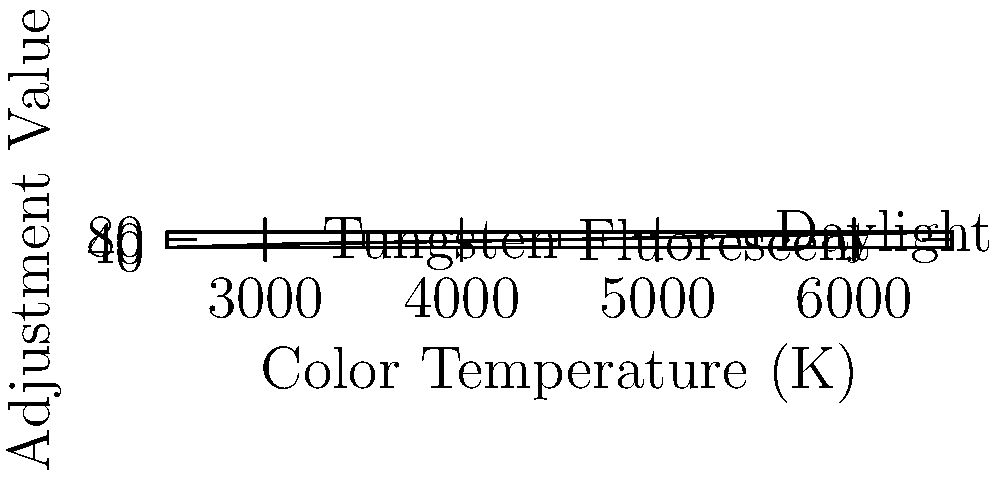In a studio setup, you're working with mixed lighting: a tungsten key light (3200K) and fluorescent fill lights (4500K). The camera is set to daylight white balance (5500K). Using the graph, calculate the total color temperature adjustment needed to balance the scene to the camera's white balance. 1. Identify the adjustment values from the graph:
   - Tungsten (3200K): 20
   - Fluorescent (4500K): 40
   - Daylight (5500K): 60

2. Calculate the difference between the camera's white balance and each light source:
   - Tungsten: 60 - 20 = 40
   - Fluorescent: 60 - 40 = 20

3. As the key light (tungsten) is the primary light source, we'll use its adjustment as the base:
   Tungsten adjustment: 40

4. The fill light (fluorescent) contributes less, so we'll add half of its adjustment:
   Fluorescent contribution: 20 / 2 = 10

5. Sum the adjustments:
   Total adjustment = Tungsten adjustment + Fluorescent contribution
   Total adjustment = 40 + 10 = 50

This means a total adjustment of +50 units is needed to balance the mixed lighting to the camera's daylight white balance.
Answer: +50 units 